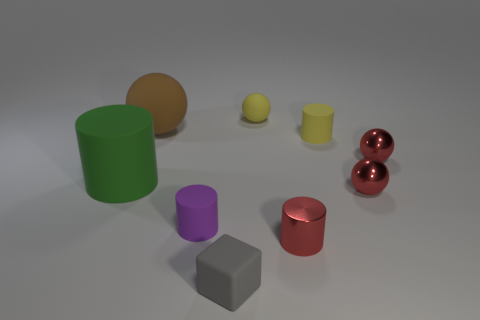Subtract all tiny yellow matte spheres. How many spheres are left? 3 Add 1 tiny yellow objects. How many objects exist? 10 Subtract all green cylinders. How many cylinders are left? 3 Subtract all cylinders. How many objects are left? 5 Subtract 1 spheres. How many spheres are left? 3 Subtract all gray balls. How many blue cubes are left? 0 Subtract all small yellow rubber balls. Subtract all red metallic objects. How many objects are left? 5 Add 1 tiny matte balls. How many tiny matte balls are left? 2 Add 7 small red things. How many small red things exist? 10 Subtract 0 gray spheres. How many objects are left? 9 